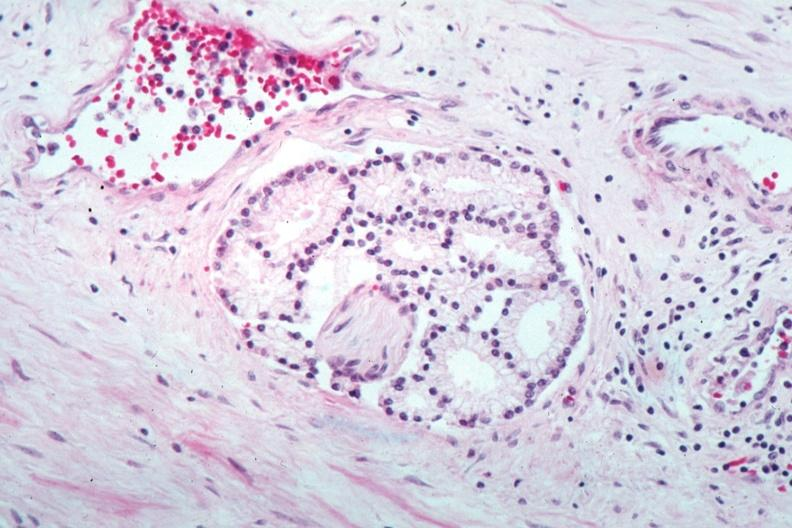how does this image show perineural invasion?
Answer the question using a single word or phrase. By a well differentiated adenocarcinoma 